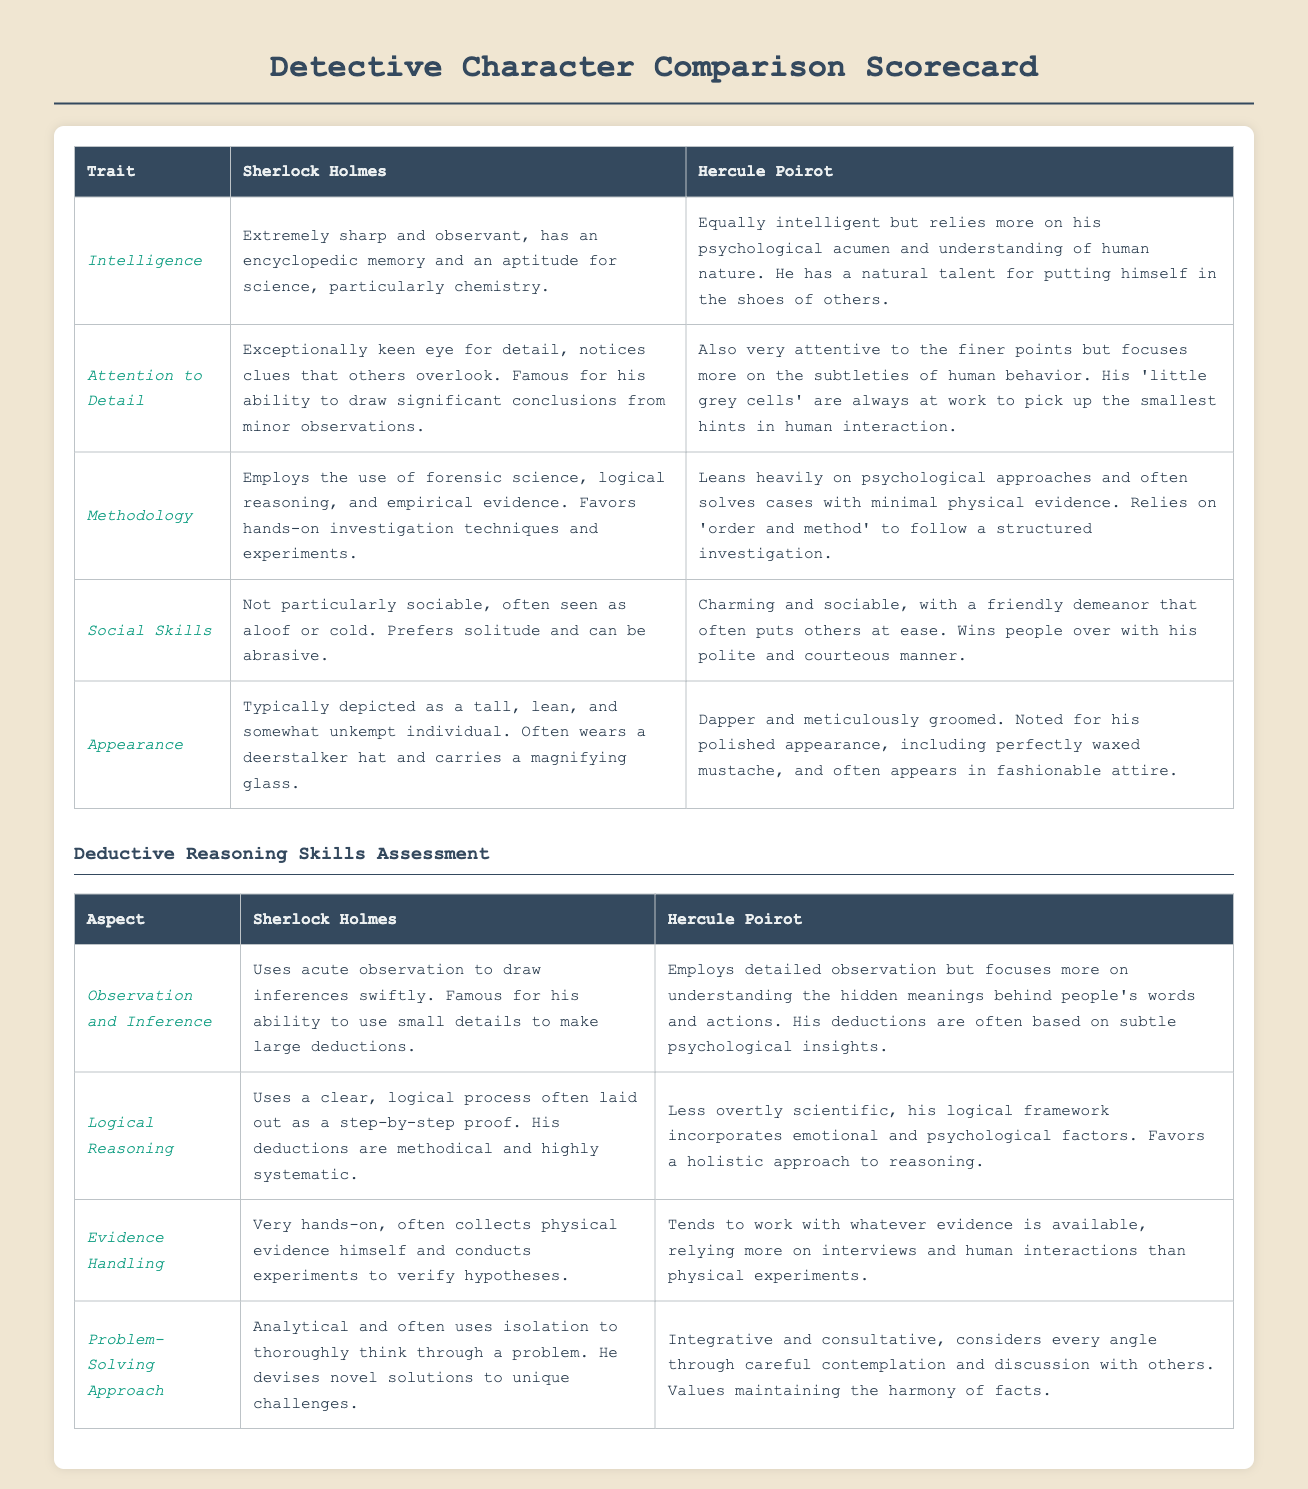What is Sherlock Holmes' primary methodology? The methodology that Sherlock Holmes employs is detailed in the scorecard, describing his use of forensic science, logical reasoning, and empirical evidence.
Answer: Forensic science, logical reasoning, and empirical evidence What traits are attributed to Hercule Poirot's intelligence? The document specifies that Poirot's intelligence is characterized by his psychological acumen and understanding of human nature, along with his talent for empathy.
Answer: Psychological acumen and understanding of human nature Which character is described as having a charming demeanor? The scorecard lists Poirot's friendly demeanor that often puts others at ease, distinguishing his social skills from Holmes.
Answer: Hercule Poirot How does Sherlock Holmes handle evidence? The document indicates that Holmes collects physical evidence himself and conducts experiments to validate his hypotheses.
Answer: Very hands-on What is Poirot's approach to problem-solving? The scorecard outlines Poirot's integrative and consultative method, which involves careful contemplation and collaboration.
Answer: Integrative and consultative 